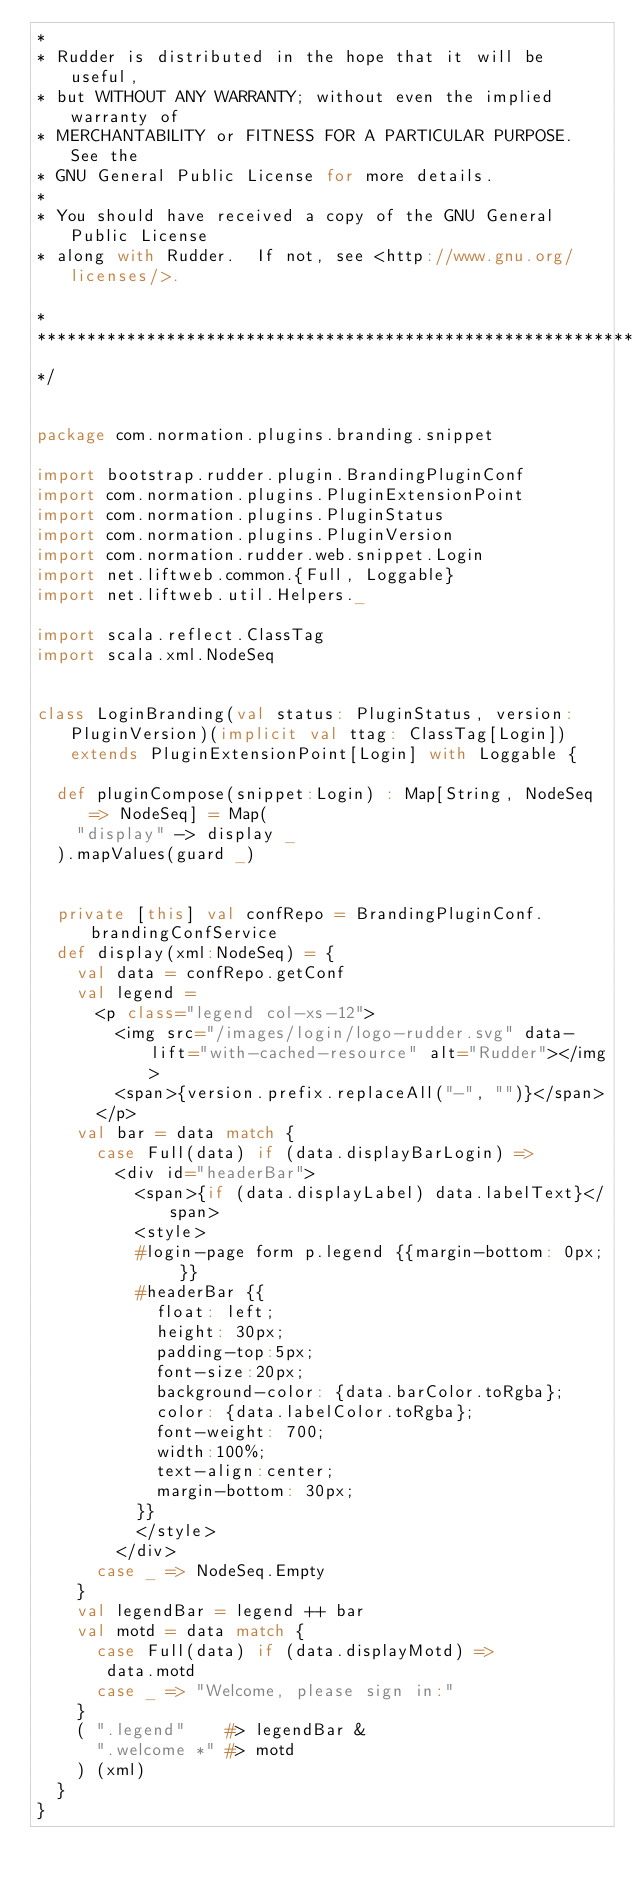Convert code to text. <code><loc_0><loc_0><loc_500><loc_500><_Scala_>*
* Rudder is distributed in the hope that it will be useful,
* but WITHOUT ANY WARRANTY; without even the implied warranty of
* MERCHANTABILITY or FITNESS FOR A PARTICULAR PURPOSE.  See the
* GNU General Public License for more details.
*
* You should have received a copy of the GNU General Public License
* along with Rudder.  If not, see <http://www.gnu.org/licenses/>.

*
*************************************************************************************
*/


package com.normation.plugins.branding.snippet

import bootstrap.rudder.plugin.BrandingPluginConf
import com.normation.plugins.PluginExtensionPoint
import com.normation.plugins.PluginStatus
import com.normation.plugins.PluginVersion
import com.normation.rudder.web.snippet.Login
import net.liftweb.common.{Full, Loggable}
import net.liftweb.util.Helpers._

import scala.reflect.ClassTag
import scala.xml.NodeSeq


class LoginBranding(val status: PluginStatus, version: PluginVersion)(implicit val ttag: ClassTag[Login]) extends PluginExtensionPoint[Login] with Loggable {

  def pluginCompose(snippet:Login) : Map[String, NodeSeq => NodeSeq] = Map(
    "display" -> display _
  ).mapValues(guard _)


  private [this] val confRepo = BrandingPluginConf.brandingConfService
  def display(xml:NodeSeq) = {
    val data = confRepo.getConf
    val legend =
      <p class="legend col-xs-12">
        <img src="/images/login/logo-rudder.svg" data-lift="with-cached-resource" alt="Rudder"></img>
        <span>{version.prefix.replaceAll("-", "")}</span>
      </p>
    val bar = data match {
      case Full(data) if (data.displayBarLogin) =>
        <div id="headerBar">
          <span>{if (data.displayLabel) data.labelText}</span>
          <style>
          #login-page form p.legend {{margin-bottom: 0px; }}
          #headerBar {{
            float: left;
            height: 30px;
            padding-top:5px;
            font-size:20px;
            background-color: {data.barColor.toRgba};
            color: {data.labelColor.toRgba};
            font-weight: 700;
            width:100%;
            text-align:center;
            margin-bottom: 30px;
          }}
          </style>
        </div>
      case _ => NodeSeq.Empty
    }
    val legendBar = legend ++ bar
    val motd = data match {
      case Full(data) if (data.displayMotd) =>
       data.motd
      case _ => "Welcome, please sign in:"
    }
    ( ".legend"    #> legendBar &
      ".welcome *" #> motd
    ) (xml)
  }
}
</code> 